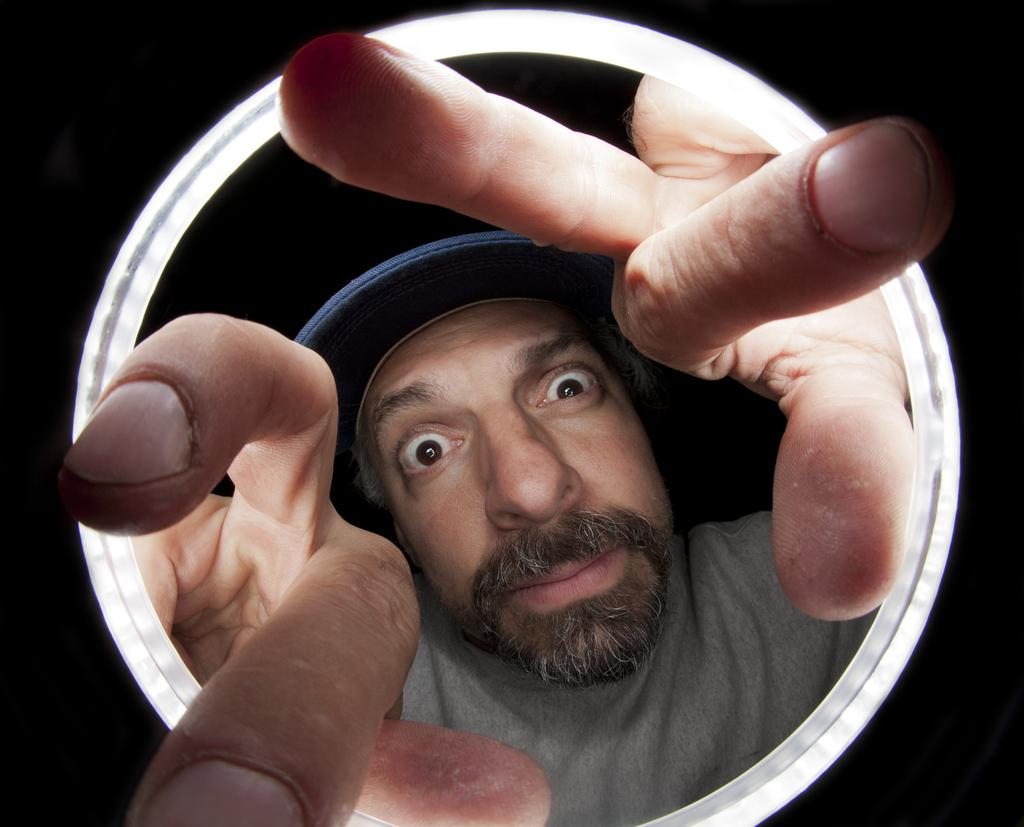Who or what is present in the image? There is a person in the image. What is the person wearing on their upper body? The person is wearing an ash-colored shirt. What type of headwear is the person wearing? The person is wearing a blue-colored hat. Can you describe the white object in the image? There is a white-colored circular object in the image. What color is the background of the image? The background of the image is black. What type of animal can be seen interacting with the person in the image? There is no animal present in the image; it only features a person wearing an ash-colored shirt and a blue-colored hat, with a white-colored circular object in front of a black background. 